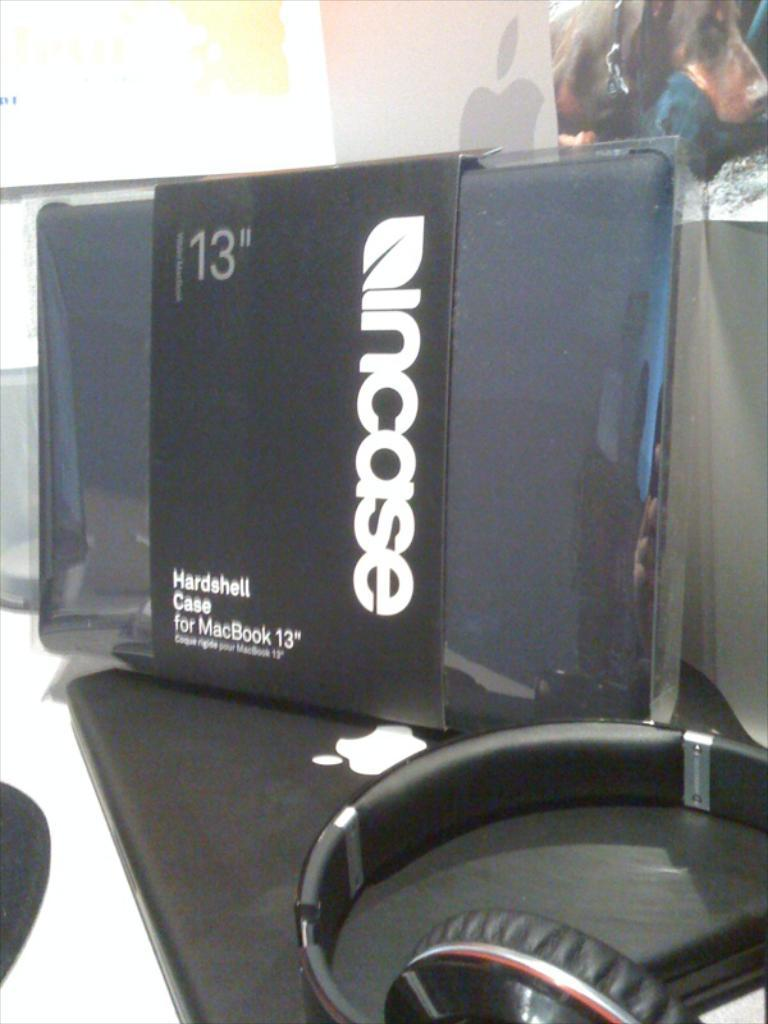What is the main object in the center of the image? There is a mobile in the center of the image. What type of device is visible in the image? There is a headset in the image. What electronic device can be seen in the image? There is a laptop in the image. What can be seen in the background of the image? There are objects in the background of the image. What type of paste is being used by the doctor in the image? There is no doctor or paste present in the image. How is the light affecting the objects in the image? There is no mention of light affecting the objects in the image; the focus is on the mobile, headset, laptop, and background objects. 